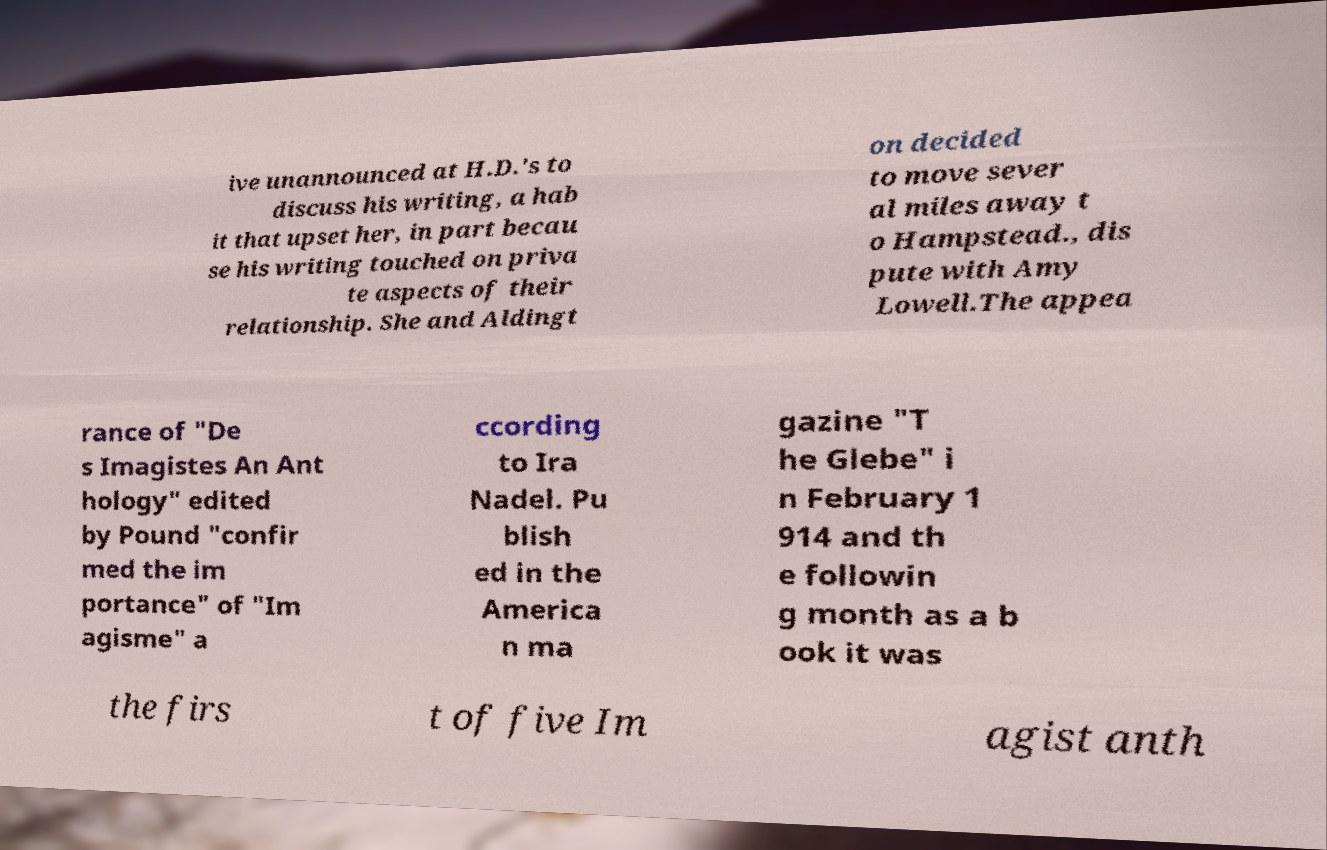Can you read and provide the text displayed in the image?This photo seems to have some interesting text. Can you extract and type it out for me? ive unannounced at H.D.'s to discuss his writing, a hab it that upset her, in part becau se his writing touched on priva te aspects of their relationship. She and Aldingt on decided to move sever al miles away t o Hampstead., dis pute with Amy Lowell.The appea rance of "De s Imagistes An Ant hology" edited by Pound "confir med the im portance" of "Im agisme" a ccording to Ira Nadel. Pu blish ed in the America n ma gazine "T he Glebe" i n February 1 914 and th e followin g month as a b ook it was the firs t of five Im agist anth 